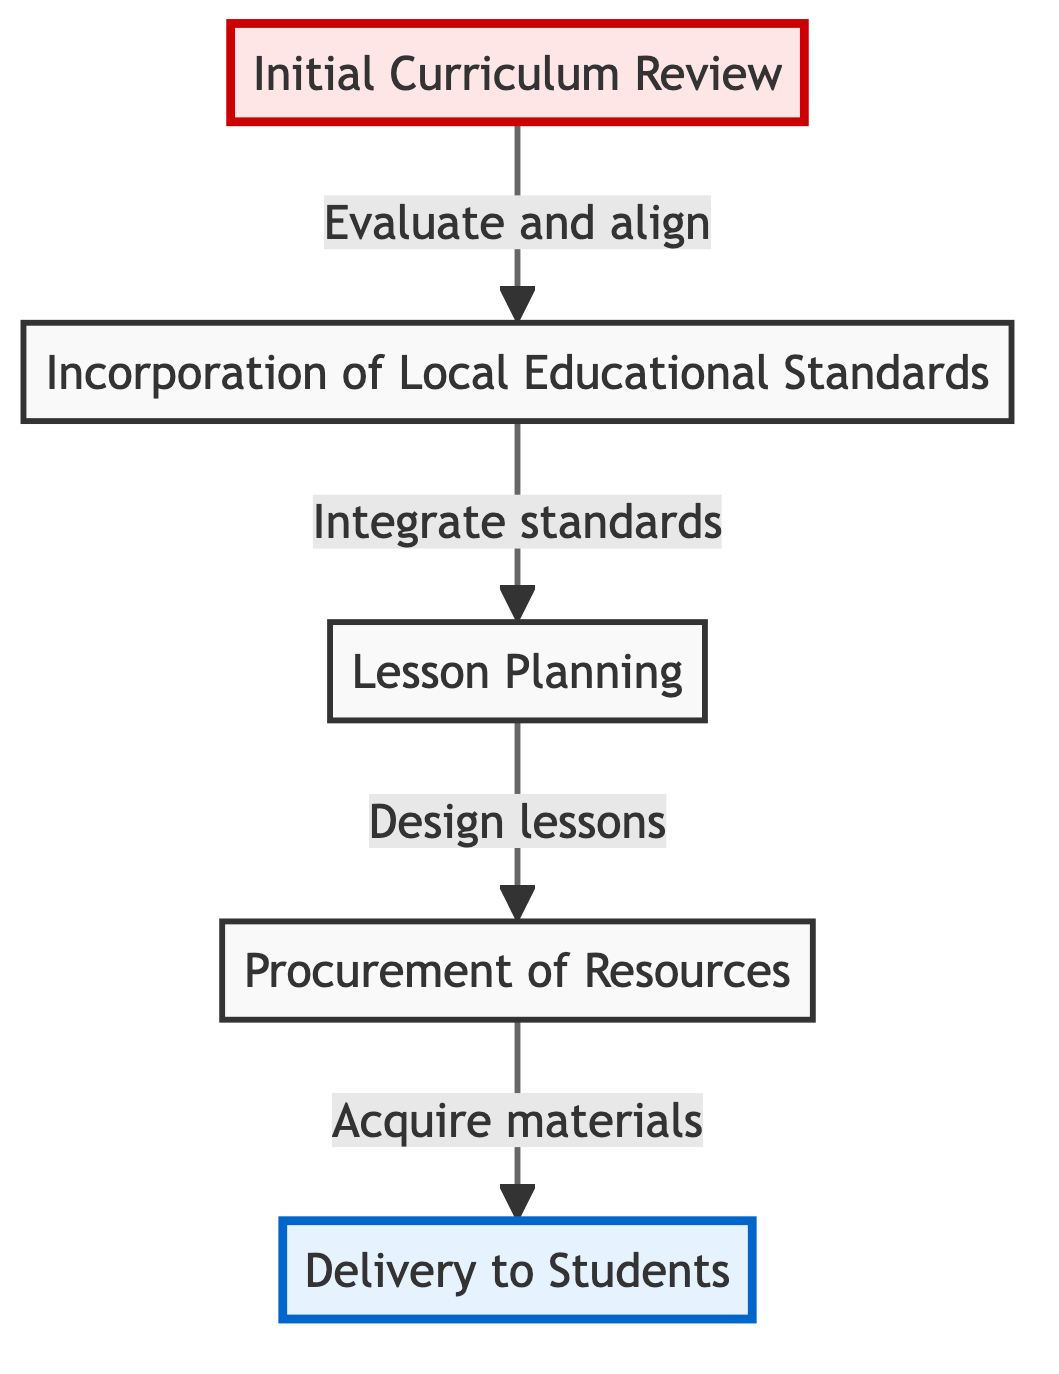What is the first step in the process? The diagram shows that the first step is "Initial Curriculum Review," which is positioned at the bottom of the flow chart.
Answer: Initial Curriculum Review How many total nodes are in the diagram? Counting each unique step listed, there are five nodes: Initial Curriculum Review, Incorporation of Local Educational Standards, Lesson Planning, Procurement of Resources, and Delivery to Students.
Answer: 5 What relationship does "Lesson Planning" have with "Procurement of Resources"? The diagram depicts a direct upward arrow from "Lesson Planning" to "Procurement of Resources," indicating that lesson planning is a prerequisite for resource procurement.
Answer: Prerequisite Which step directly precedes "Delivery to Students"? According to the diagram, "Procurement of Resources" is directly below and thus precedes "Delivery to Students."
Answer: Procurement of Resources What is the ultimate goal of the curriculum design process? The end goal represented in the diagram is found at the top node, which is "Delivery to Students." This indicates that all preceding steps aim to successfully implement the curriculum.
Answer: Delivery to Students What is required before lesson planning can occur? The sequence shows that "Incorporation of Local Educational Standards" must be done before "Lesson Planning" can take place, as indicated by the upward arrow from the former to the latter.
Answer: Incorporation of Local Educational Standards Which node deals with aligning the curriculum to national standards? The node specifically dedicated to aligning the curriculum with educational standards is "Incorporation of Local Educational Standards."
Answer: Incorporation of Local Educational Standards What is the flow direction of the diagram? The arrows in the diagram point upward, indicating a bottom-to-top flow in the process of curriculum design and implementation.
Answer: Upward 